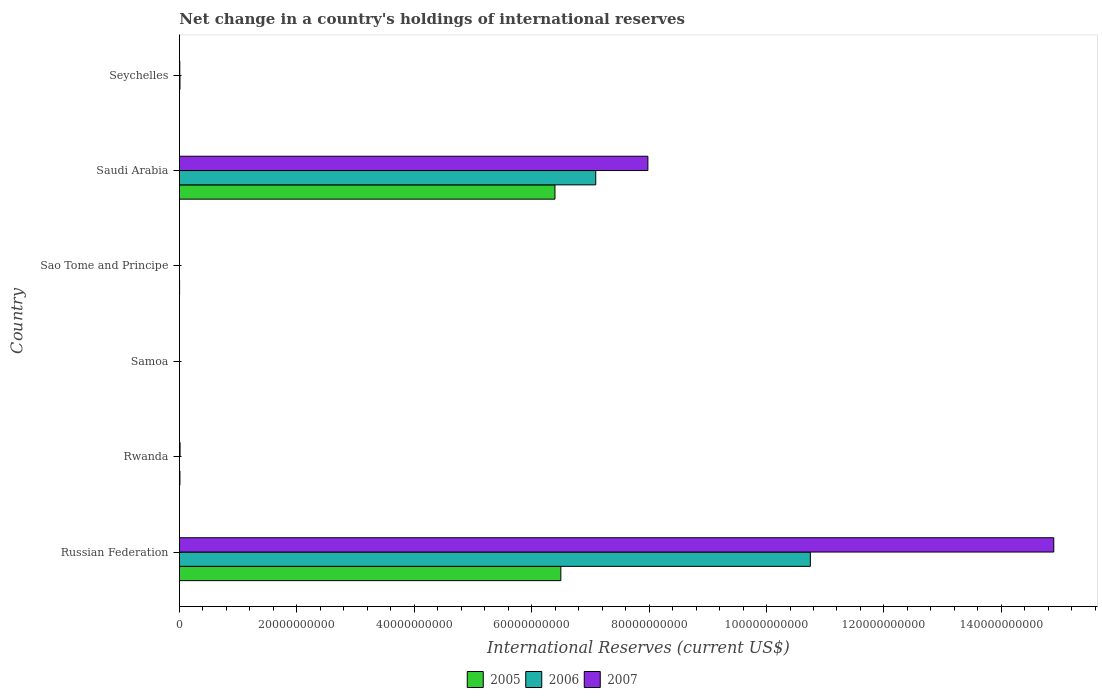Are the number of bars per tick equal to the number of legend labels?
Your answer should be compact. No. What is the label of the 6th group of bars from the top?
Offer a terse response. Russian Federation. In how many cases, is the number of bars for a given country not equal to the number of legend labels?
Make the answer very short. 4. What is the international reserves in 2007 in Saudi Arabia?
Provide a succinct answer. 7.98e+1. Across all countries, what is the maximum international reserves in 2006?
Give a very brief answer. 1.07e+11. In which country was the international reserves in 2007 maximum?
Make the answer very short. Russian Federation. What is the total international reserves in 2007 in the graph?
Offer a terse response. 2.29e+11. What is the difference between the international reserves in 2007 in Saudi Arabia and that in Seychelles?
Provide a short and direct response. 7.97e+1. What is the difference between the international reserves in 2007 in Seychelles and the international reserves in 2006 in Sao Tome and Principe?
Your answer should be very brief. 6.11e+07. What is the average international reserves in 2007 per country?
Keep it short and to the point. 3.81e+1. What is the difference between the international reserves in 2005 and international reserves in 2007 in Saudi Arabia?
Provide a succinct answer. -1.58e+1. What is the ratio of the international reserves in 2005 in Rwanda to that in Saudi Arabia?
Offer a terse response. 0. What is the difference between the highest and the second highest international reserves in 2006?
Your answer should be very brief. 3.66e+1. What is the difference between the highest and the lowest international reserves in 2006?
Your answer should be very brief. 1.07e+11. Is it the case that in every country, the sum of the international reserves in 2005 and international reserves in 2006 is greater than the international reserves in 2007?
Give a very brief answer. No. How many countries are there in the graph?
Your response must be concise. 6. Are the values on the major ticks of X-axis written in scientific E-notation?
Keep it short and to the point. No. Does the graph contain any zero values?
Your answer should be compact. Yes. Does the graph contain grids?
Your answer should be compact. No. What is the title of the graph?
Provide a short and direct response. Net change in a country's holdings of international reserves. What is the label or title of the X-axis?
Provide a short and direct response. International Reserves (current US$). What is the label or title of the Y-axis?
Provide a short and direct response. Country. What is the International Reserves (current US$) in 2005 in Russian Federation?
Offer a terse response. 6.50e+1. What is the International Reserves (current US$) of 2006 in Russian Federation?
Your response must be concise. 1.07e+11. What is the International Reserves (current US$) in 2007 in Russian Federation?
Ensure brevity in your answer.  1.49e+11. What is the International Reserves (current US$) in 2005 in Rwanda?
Your answer should be compact. 8.77e+07. What is the International Reserves (current US$) in 2006 in Rwanda?
Provide a succinct answer. 0. What is the International Reserves (current US$) in 2007 in Rwanda?
Make the answer very short. 1.11e+08. What is the International Reserves (current US$) of 2005 in Samoa?
Provide a succinct answer. 0. What is the International Reserves (current US$) in 2005 in Sao Tome and Principe?
Your response must be concise. 3.05e+07. What is the International Reserves (current US$) in 2006 in Sao Tome and Principe?
Your answer should be very brief. 1.11e+05. What is the International Reserves (current US$) of 2005 in Saudi Arabia?
Make the answer very short. 6.40e+1. What is the International Reserves (current US$) in 2006 in Saudi Arabia?
Your answer should be compact. 7.09e+1. What is the International Reserves (current US$) of 2007 in Saudi Arabia?
Provide a succinct answer. 7.98e+1. What is the International Reserves (current US$) of 2005 in Seychelles?
Your response must be concise. 0. What is the International Reserves (current US$) in 2006 in Seychelles?
Offer a very short reply. 9.32e+07. What is the International Reserves (current US$) in 2007 in Seychelles?
Keep it short and to the point. 6.12e+07. Across all countries, what is the maximum International Reserves (current US$) in 2005?
Keep it short and to the point. 6.50e+1. Across all countries, what is the maximum International Reserves (current US$) in 2006?
Ensure brevity in your answer.  1.07e+11. Across all countries, what is the maximum International Reserves (current US$) in 2007?
Offer a very short reply. 1.49e+11. Across all countries, what is the minimum International Reserves (current US$) in 2006?
Offer a terse response. 0. Across all countries, what is the minimum International Reserves (current US$) of 2007?
Provide a succinct answer. 0. What is the total International Reserves (current US$) of 2005 in the graph?
Your answer should be very brief. 1.29e+11. What is the total International Reserves (current US$) of 2006 in the graph?
Your answer should be very brief. 1.78e+11. What is the total International Reserves (current US$) in 2007 in the graph?
Your answer should be very brief. 2.29e+11. What is the difference between the International Reserves (current US$) in 2005 in Russian Federation and that in Rwanda?
Make the answer very short. 6.49e+1. What is the difference between the International Reserves (current US$) of 2007 in Russian Federation and that in Rwanda?
Keep it short and to the point. 1.49e+11. What is the difference between the International Reserves (current US$) of 2005 in Russian Federation and that in Sao Tome and Principe?
Keep it short and to the point. 6.49e+1. What is the difference between the International Reserves (current US$) in 2006 in Russian Federation and that in Sao Tome and Principe?
Your response must be concise. 1.07e+11. What is the difference between the International Reserves (current US$) in 2005 in Russian Federation and that in Saudi Arabia?
Offer a terse response. 9.99e+08. What is the difference between the International Reserves (current US$) of 2006 in Russian Federation and that in Saudi Arabia?
Offer a very short reply. 3.66e+1. What is the difference between the International Reserves (current US$) of 2007 in Russian Federation and that in Saudi Arabia?
Provide a short and direct response. 6.91e+1. What is the difference between the International Reserves (current US$) of 2006 in Russian Federation and that in Seychelles?
Provide a succinct answer. 1.07e+11. What is the difference between the International Reserves (current US$) in 2007 in Russian Federation and that in Seychelles?
Provide a succinct answer. 1.49e+11. What is the difference between the International Reserves (current US$) of 2005 in Rwanda and that in Sao Tome and Principe?
Ensure brevity in your answer.  5.72e+07. What is the difference between the International Reserves (current US$) of 2005 in Rwanda and that in Saudi Arabia?
Your answer should be compact. -6.39e+1. What is the difference between the International Reserves (current US$) of 2007 in Rwanda and that in Saudi Arabia?
Make the answer very short. -7.97e+1. What is the difference between the International Reserves (current US$) of 2007 in Rwanda and that in Seychelles?
Provide a short and direct response. 4.94e+07. What is the difference between the International Reserves (current US$) of 2005 in Sao Tome and Principe and that in Saudi Arabia?
Give a very brief answer. -6.39e+1. What is the difference between the International Reserves (current US$) of 2006 in Sao Tome and Principe and that in Saudi Arabia?
Offer a very short reply. -7.09e+1. What is the difference between the International Reserves (current US$) of 2006 in Sao Tome and Principe and that in Seychelles?
Offer a very short reply. -9.31e+07. What is the difference between the International Reserves (current US$) in 2006 in Saudi Arabia and that in Seychelles?
Your response must be concise. 7.08e+1. What is the difference between the International Reserves (current US$) of 2007 in Saudi Arabia and that in Seychelles?
Make the answer very short. 7.97e+1. What is the difference between the International Reserves (current US$) in 2005 in Russian Federation and the International Reserves (current US$) in 2007 in Rwanda?
Keep it short and to the point. 6.49e+1. What is the difference between the International Reserves (current US$) of 2006 in Russian Federation and the International Reserves (current US$) of 2007 in Rwanda?
Your answer should be compact. 1.07e+11. What is the difference between the International Reserves (current US$) of 2005 in Russian Federation and the International Reserves (current US$) of 2006 in Sao Tome and Principe?
Give a very brief answer. 6.50e+1. What is the difference between the International Reserves (current US$) of 2005 in Russian Federation and the International Reserves (current US$) of 2006 in Saudi Arabia?
Provide a succinct answer. -5.94e+09. What is the difference between the International Reserves (current US$) of 2005 in Russian Federation and the International Reserves (current US$) of 2007 in Saudi Arabia?
Provide a short and direct response. -1.48e+1. What is the difference between the International Reserves (current US$) in 2006 in Russian Federation and the International Reserves (current US$) in 2007 in Saudi Arabia?
Give a very brief answer. 2.77e+1. What is the difference between the International Reserves (current US$) in 2005 in Russian Federation and the International Reserves (current US$) in 2006 in Seychelles?
Your response must be concise. 6.49e+1. What is the difference between the International Reserves (current US$) of 2005 in Russian Federation and the International Reserves (current US$) of 2007 in Seychelles?
Offer a terse response. 6.49e+1. What is the difference between the International Reserves (current US$) in 2006 in Russian Federation and the International Reserves (current US$) in 2007 in Seychelles?
Offer a very short reply. 1.07e+11. What is the difference between the International Reserves (current US$) of 2005 in Rwanda and the International Reserves (current US$) of 2006 in Sao Tome and Principe?
Your response must be concise. 8.76e+07. What is the difference between the International Reserves (current US$) in 2005 in Rwanda and the International Reserves (current US$) in 2006 in Saudi Arabia?
Offer a very short reply. -7.08e+1. What is the difference between the International Reserves (current US$) of 2005 in Rwanda and the International Reserves (current US$) of 2007 in Saudi Arabia?
Your answer should be very brief. -7.97e+1. What is the difference between the International Reserves (current US$) in 2005 in Rwanda and the International Reserves (current US$) in 2006 in Seychelles?
Give a very brief answer. -5.55e+06. What is the difference between the International Reserves (current US$) in 2005 in Rwanda and the International Reserves (current US$) in 2007 in Seychelles?
Give a very brief answer. 2.64e+07. What is the difference between the International Reserves (current US$) in 2005 in Sao Tome and Principe and the International Reserves (current US$) in 2006 in Saudi Arabia?
Your answer should be compact. -7.09e+1. What is the difference between the International Reserves (current US$) in 2005 in Sao Tome and Principe and the International Reserves (current US$) in 2007 in Saudi Arabia?
Make the answer very short. -7.98e+1. What is the difference between the International Reserves (current US$) of 2006 in Sao Tome and Principe and the International Reserves (current US$) of 2007 in Saudi Arabia?
Provide a succinct answer. -7.98e+1. What is the difference between the International Reserves (current US$) of 2005 in Sao Tome and Principe and the International Reserves (current US$) of 2006 in Seychelles?
Your answer should be compact. -6.27e+07. What is the difference between the International Reserves (current US$) of 2005 in Sao Tome and Principe and the International Reserves (current US$) of 2007 in Seychelles?
Offer a terse response. -3.07e+07. What is the difference between the International Reserves (current US$) in 2006 in Sao Tome and Principe and the International Reserves (current US$) in 2007 in Seychelles?
Give a very brief answer. -6.11e+07. What is the difference between the International Reserves (current US$) in 2005 in Saudi Arabia and the International Reserves (current US$) in 2006 in Seychelles?
Offer a very short reply. 6.39e+1. What is the difference between the International Reserves (current US$) in 2005 in Saudi Arabia and the International Reserves (current US$) in 2007 in Seychelles?
Make the answer very short. 6.39e+1. What is the difference between the International Reserves (current US$) of 2006 in Saudi Arabia and the International Reserves (current US$) of 2007 in Seychelles?
Make the answer very short. 7.08e+1. What is the average International Reserves (current US$) in 2005 per country?
Provide a short and direct response. 2.15e+1. What is the average International Reserves (current US$) of 2006 per country?
Provide a short and direct response. 2.97e+1. What is the average International Reserves (current US$) in 2007 per country?
Your answer should be compact. 3.81e+1. What is the difference between the International Reserves (current US$) in 2005 and International Reserves (current US$) in 2006 in Russian Federation?
Provide a succinct answer. -4.25e+1. What is the difference between the International Reserves (current US$) in 2005 and International Reserves (current US$) in 2007 in Russian Federation?
Make the answer very short. -8.40e+1. What is the difference between the International Reserves (current US$) in 2006 and International Reserves (current US$) in 2007 in Russian Federation?
Make the answer very short. -4.15e+1. What is the difference between the International Reserves (current US$) of 2005 and International Reserves (current US$) of 2007 in Rwanda?
Make the answer very short. -2.29e+07. What is the difference between the International Reserves (current US$) of 2005 and International Reserves (current US$) of 2006 in Sao Tome and Principe?
Your response must be concise. 3.04e+07. What is the difference between the International Reserves (current US$) of 2005 and International Reserves (current US$) of 2006 in Saudi Arabia?
Your answer should be very brief. -6.94e+09. What is the difference between the International Reserves (current US$) of 2005 and International Reserves (current US$) of 2007 in Saudi Arabia?
Give a very brief answer. -1.58e+1. What is the difference between the International Reserves (current US$) in 2006 and International Reserves (current US$) in 2007 in Saudi Arabia?
Your response must be concise. -8.88e+09. What is the difference between the International Reserves (current US$) in 2006 and International Reserves (current US$) in 2007 in Seychelles?
Make the answer very short. 3.20e+07. What is the ratio of the International Reserves (current US$) of 2005 in Russian Federation to that in Rwanda?
Offer a terse response. 740.95. What is the ratio of the International Reserves (current US$) of 2007 in Russian Federation to that in Rwanda?
Ensure brevity in your answer.  1346.43. What is the ratio of the International Reserves (current US$) in 2005 in Russian Federation to that in Sao Tome and Principe?
Your answer should be compact. 2129.07. What is the ratio of the International Reserves (current US$) of 2006 in Russian Federation to that in Sao Tome and Principe?
Your answer should be very brief. 9.69e+05. What is the ratio of the International Reserves (current US$) of 2005 in Russian Federation to that in Saudi Arabia?
Make the answer very short. 1.02. What is the ratio of the International Reserves (current US$) of 2006 in Russian Federation to that in Saudi Arabia?
Your response must be concise. 1.52. What is the ratio of the International Reserves (current US$) in 2007 in Russian Federation to that in Saudi Arabia?
Provide a short and direct response. 1.87. What is the ratio of the International Reserves (current US$) in 2006 in Russian Federation to that in Seychelles?
Make the answer very short. 1152.67. What is the ratio of the International Reserves (current US$) in 2007 in Russian Federation to that in Seychelles?
Provide a succinct answer. 2431.6. What is the ratio of the International Reserves (current US$) in 2005 in Rwanda to that in Sao Tome and Principe?
Your answer should be compact. 2.87. What is the ratio of the International Reserves (current US$) of 2005 in Rwanda to that in Saudi Arabia?
Offer a very short reply. 0. What is the ratio of the International Reserves (current US$) of 2007 in Rwanda to that in Saudi Arabia?
Your response must be concise. 0. What is the ratio of the International Reserves (current US$) in 2007 in Rwanda to that in Seychelles?
Provide a short and direct response. 1.81. What is the ratio of the International Reserves (current US$) of 2005 in Sao Tome and Principe to that in Saudi Arabia?
Make the answer very short. 0. What is the ratio of the International Reserves (current US$) in 2006 in Sao Tome and Principe to that in Saudi Arabia?
Offer a terse response. 0. What is the ratio of the International Reserves (current US$) of 2006 in Sao Tome and Principe to that in Seychelles?
Provide a succinct answer. 0. What is the ratio of the International Reserves (current US$) in 2006 in Saudi Arabia to that in Seychelles?
Make the answer very short. 760.58. What is the ratio of the International Reserves (current US$) in 2007 in Saudi Arabia to that in Seychelles?
Your answer should be very brief. 1302.82. What is the difference between the highest and the second highest International Reserves (current US$) in 2005?
Your answer should be compact. 9.99e+08. What is the difference between the highest and the second highest International Reserves (current US$) in 2006?
Provide a succinct answer. 3.66e+1. What is the difference between the highest and the second highest International Reserves (current US$) of 2007?
Provide a succinct answer. 6.91e+1. What is the difference between the highest and the lowest International Reserves (current US$) in 2005?
Keep it short and to the point. 6.50e+1. What is the difference between the highest and the lowest International Reserves (current US$) in 2006?
Provide a short and direct response. 1.07e+11. What is the difference between the highest and the lowest International Reserves (current US$) in 2007?
Offer a very short reply. 1.49e+11. 